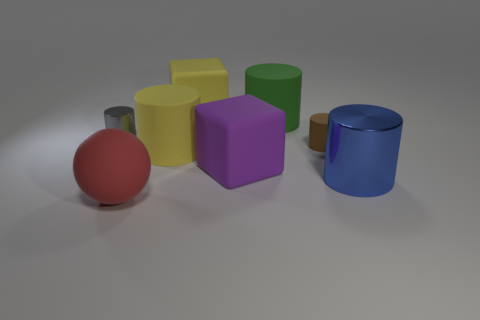Subtract all yellow cylinders. How many cylinders are left? 4 Subtract all tiny rubber cylinders. How many cylinders are left? 4 Add 2 yellow matte cubes. How many objects exist? 10 Subtract all cyan cylinders. Subtract all blue balls. How many cylinders are left? 5 Subtract all cylinders. How many objects are left? 3 Add 3 gray shiny things. How many gray shiny things exist? 4 Subtract 0 purple cylinders. How many objects are left? 8 Subtract all small green cylinders. Subtract all shiny cylinders. How many objects are left? 6 Add 3 large red spheres. How many large red spheres are left? 4 